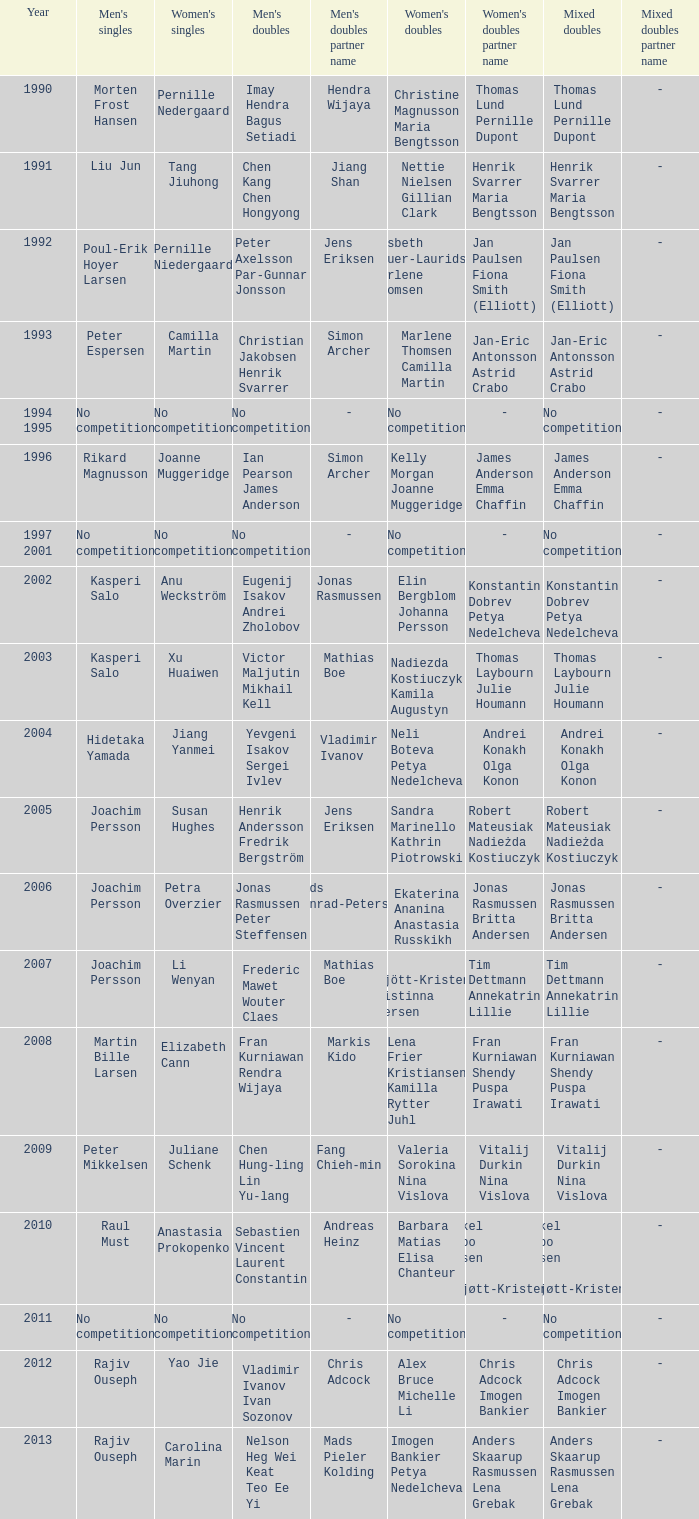Who won the Mixed Doubles in 2007? Tim Dettmann Annekatrin Lillie. 